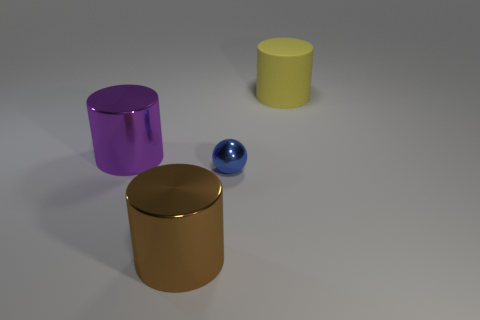How are the objects arranged relative to each other? The objects are spaced apart on a flat surface. The small blue sphere is positioned in front of the largest gold cylinder, with the purple and yellow cylinders to the left of the gold cylinder when viewed from the camera perspective. 